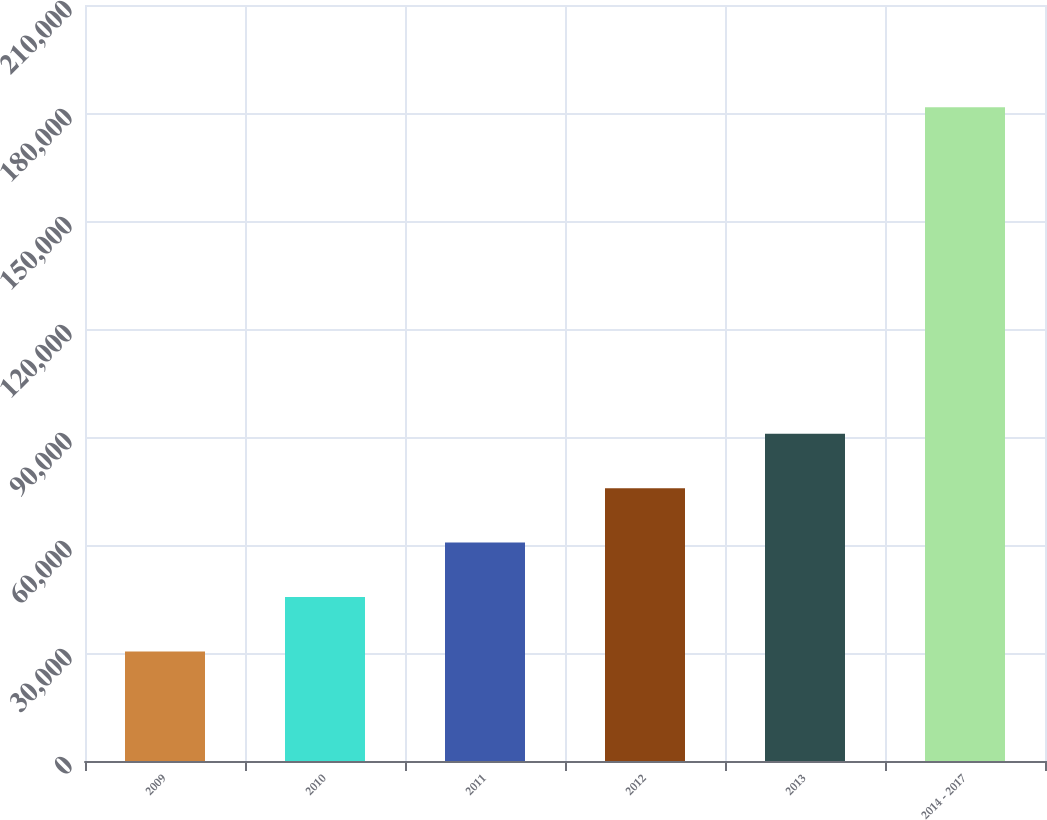Convert chart. <chart><loc_0><loc_0><loc_500><loc_500><bar_chart><fcel>2009<fcel>2010<fcel>2011<fcel>2012<fcel>2013<fcel>2014 - 2017<nl><fcel>30432<fcel>45548<fcel>60664<fcel>75780<fcel>90896<fcel>181592<nl></chart> 